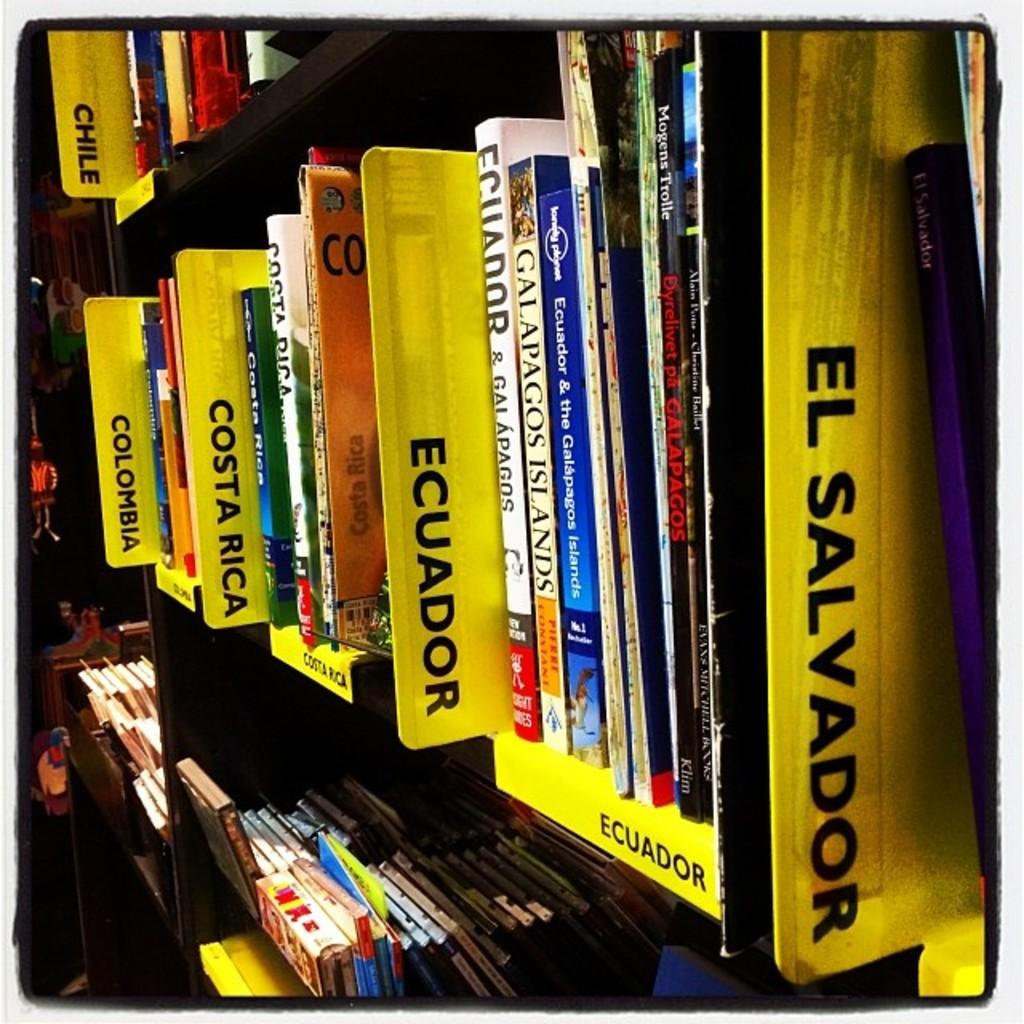<image>
Relay a brief, clear account of the picture shown. A bookshelf has yellow dividers with country names to identify the specific section of books. 